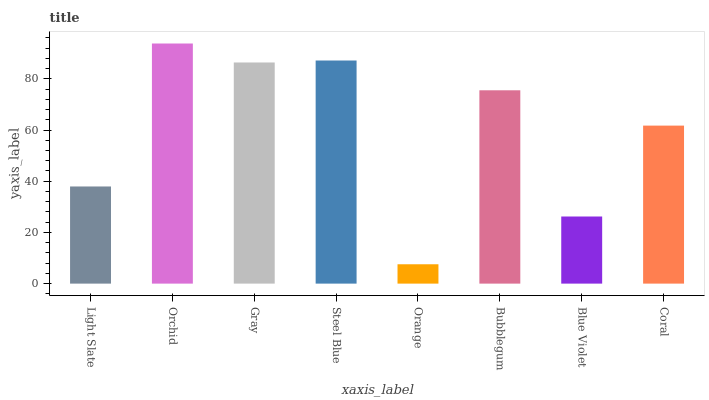Is Gray the minimum?
Answer yes or no. No. Is Gray the maximum?
Answer yes or no. No. Is Orchid greater than Gray?
Answer yes or no. Yes. Is Gray less than Orchid?
Answer yes or no. Yes. Is Gray greater than Orchid?
Answer yes or no. No. Is Orchid less than Gray?
Answer yes or no. No. Is Bubblegum the high median?
Answer yes or no. Yes. Is Coral the low median?
Answer yes or no. Yes. Is Blue Violet the high median?
Answer yes or no. No. Is Light Slate the low median?
Answer yes or no. No. 